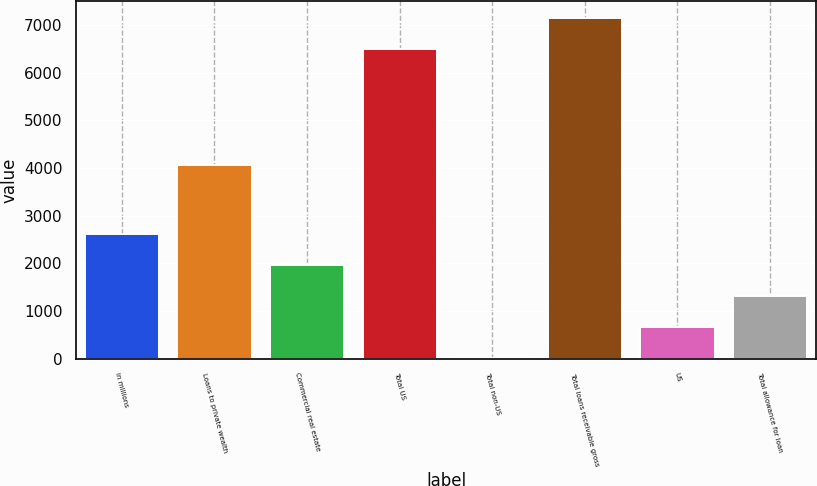<chart> <loc_0><loc_0><loc_500><loc_500><bar_chart><fcel>in millions<fcel>Loans to private wealth<fcel>Commercial real estate<fcel>Total US<fcel>Total non-US<fcel>Total loans receivable gross<fcel>US<fcel>Total allowance for loan<nl><fcel>2609.6<fcel>4057<fcel>1960.7<fcel>6489<fcel>14<fcel>7137.9<fcel>662.9<fcel>1311.8<nl></chart> 